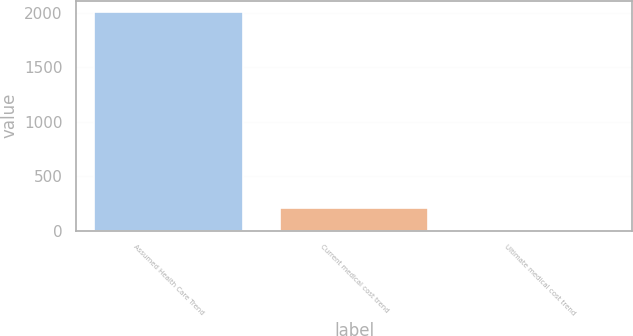Convert chart. <chart><loc_0><loc_0><loc_500><loc_500><bar_chart><fcel>Assumed Health Care Trend<fcel>Current medical cost trend<fcel>Ultimate medical cost trend<nl><fcel>2012<fcel>205.25<fcel>4.5<nl></chart> 